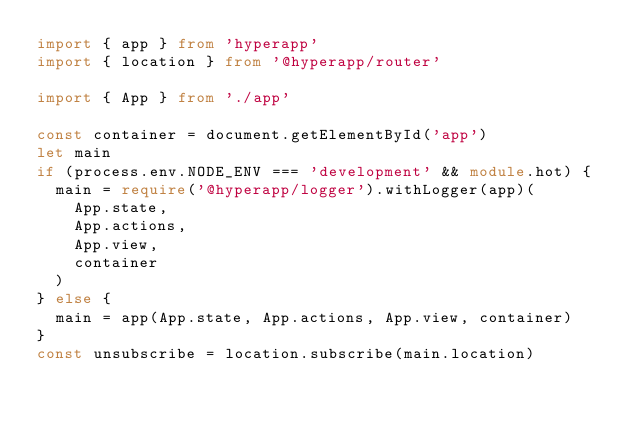<code> <loc_0><loc_0><loc_500><loc_500><_TypeScript_>import { app } from 'hyperapp'
import { location } from '@hyperapp/router'

import { App } from './app'

const container = document.getElementById('app')
let main
if (process.env.NODE_ENV === 'development' && module.hot) {
  main = require('@hyperapp/logger').withLogger(app)(
    App.state,
    App.actions,
    App.view,
    container
  )
} else {
  main = app(App.state, App.actions, App.view, container)
}
const unsubscribe = location.subscribe(main.location)
</code> 